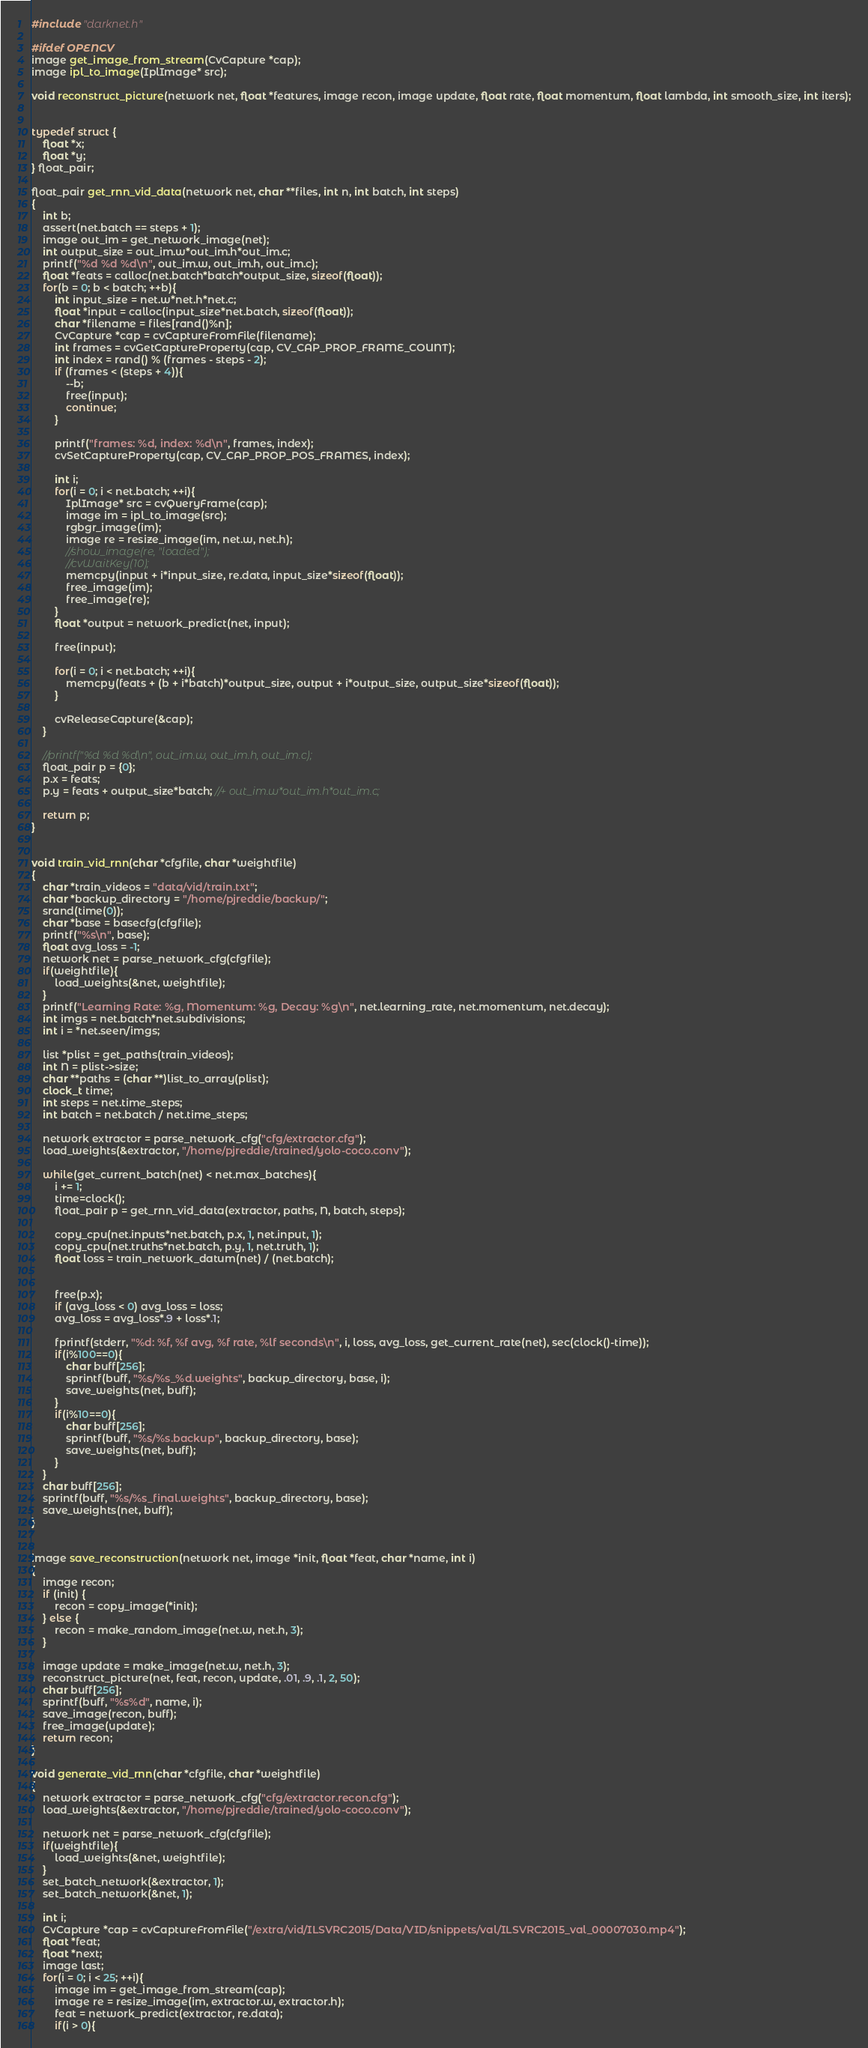<code> <loc_0><loc_0><loc_500><loc_500><_C_>#include "darknet.h"

#ifdef OPENCV
image get_image_from_stream(CvCapture *cap);
image ipl_to_image(IplImage* src);

void reconstruct_picture(network net, float *features, image recon, image update, float rate, float momentum, float lambda, int smooth_size, int iters);


typedef struct {
    float *x;
    float *y;
} float_pair;

float_pair get_rnn_vid_data(network net, char **files, int n, int batch, int steps)
{
    int b;
    assert(net.batch == steps + 1);
    image out_im = get_network_image(net);
    int output_size = out_im.w*out_im.h*out_im.c;
    printf("%d %d %d\n", out_im.w, out_im.h, out_im.c);
    float *feats = calloc(net.batch*batch*output_size, sizeof(float));
    for(b = 0; b < batch; ++b){
        int input_size = net.w*net.h*net.c;
        float *input = calloc(input_size*net.batch, sizeof(float));
        char *filename = files[rand()%n];
        CvCapture *cap = cvCaptureFromFile(filename);
        int frames = cvGetCaptureProperty(cap, CV_CAP_PROP_FRAME_COUNT);
        int index = rand() % (frames - steps - 2);
        if (frames < (steps + 4)){
            --b;
            free(input);
            continue;
        }

        printf("frames: %d, index: %d\n", frames, index);
        cvSetCaptureProperty(cap, CV_CAP_PROP_POS_FRAMES, index);

        int i;
        for(i = 0; i < net.batch; ++i){
            IplImage* src = cvQueryFrame(cap);
            image im = ipl_to_image(src);
            rgbgr_image(im);
            image re = resize_image(im, net.w, net.h);
            //show_image(re, "loaded");
            //cvWaitKey(10);
            memcpy(input + i*input_size, re.data, input_size*sizeof(float));
            free_image(im);
            free_image(re);
        }
        float *output = network_predict(net, input);

        free(input);

        for(i = 0; i < net.batch; ++i){
            memcpy(feats + (b + i*batch)*output_size, output + i*output_size, output_size*sizeof(float));
        }

        cvReleaseCapture(&cap);
    }

    //printf("%d %d %d\n", out_im.w, out_im.h, out_im.c);
    float_pair p = {0};
    p.x = feats;
    p.y = feats + output_size*batch; //+ out_im.w*out_im.h*out_im.c;

    return p;
}


void train_vid_rnn(char *cfgfile, char *weightfile)
{
    char *train_videos = "data/vid/train.txt";
    char *backup_directory = "/home/pjreddie/backup/";
    srand(time(0));
    char *base = basecfg(cfgfile);
    printf("%s\n", base);
    float avg_loss = -1;
    network net = parse_network_cfg(cfgfile);
    if(weightfile){
        load_weights(&net, weightfile);
    }
    printf("Learning Rate: %g, Momentum: %g, Decay: %g\n", net.learning_rate, net.momentum, net.decay);
    int imgs = net.batch*net.subdivisions;
    int i = *net.seen/imgs;

    list *plist = get_paths(train_videos);
    int N = plist->size;
    char **paths = (char **)list_to_array(plist);
    clock_t time;
    int steps = net.time_steps;
    int batch = net.batch / net.time_steps;

    network extractor = parse_network_cfg("cfg/extractor.cfg");
    load_weights(&extractor, "/home/pjreddie/trained/yolo-coco.conv");

    while(get_current_batch(net) < net.max_batches){
        i += 1;
        time=clock();
        float_pair p = get_rnn_vid_data(extractor, paths, N, batch, steps);

        copy_cpu(net.inputs*net.batch, p.x, 1, net.input, 1);
        copy_cpu(net.truths*net.batch, p.y, 1, net.truth, 1);
        float loss = train_network_datum(net) / (net.batch);


        free(p.x);
        if (avg_loss < 0) avg_loss = loss;
        avg_loss = avg_loss*.9 + loss*.1;

        fprintf(stderr, "%d: %f, %f avg, %f rate, %lf seconds\n", i, loss, avg_loss, get_current_rate(net), sec(clock()-time));
        if(i%100==0){
            char buff[256];
            sprintf(buff, "%s/%s_%d.weights", backup_directory, base, i);
            save_weights(net, buff);
        }
        if(i%10==0){
            char buff[256];
            sprintf(buff, "%s/%s.backup", backup_directory, base);
            save_weights(net, buff);
        }
    }
    char buff[256];
    sprintf(buff, "%s/%s_final.weights", backup_directory, base);
    save_weights(net, buff);
}


image save_reconstruction(network net, image *init, float *feat, char *name, int i)
{
    image recon;
    if (init) {
        recon = copy_image(*init);
    } else {
        recon = make_random_image(net.w, net.h, 3);
    }

    image update = make_image(net.w, net.h, 3);
    reconstruct_picture(net, feat, recon, update, .01, .9, .1, 2, 50);
    char buff[256];
    sprintf(buff, "%s%d", name, i);
    save_image(recon, buff);
    free_image(update);
    return recon;
}

void generate_vid_rnn(char *cfgfile, char *weightfile)
{
    network extractor = parse_network_cfg("cfg/extractor.recon.cfg");
    load_weights(&extractor, "/home/pjreddie/trained/yolo-coco.conv");

    network net = parse_network_cfg(cfgfile);
    if(weightfile){
        load_weights(&net, weightfile);
    }
    set_batch_network(&extractor, 1);
    set_batch_network(&net, 1);

    int i;
    CvCapture *cap = cvCaptureFromFile("/extra/vid/ILSVRC2015/Data/VID/snippets/val/ILSVRC2015_val_00007030.mp4");
    float *feat;
    float *next;
    image last;
    for(i = 0; i < 25; ++i){
        image im = get_image_from_stream(cap);
        image re = resize_image(im, extractor.w, extractor.h);
        feat = network_predict(extractor, re.data);
        if(i > 0){</code> 